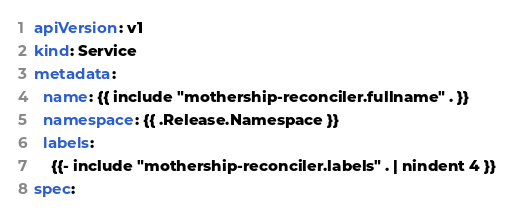<code> <loc_0><loc_0><loc_500><loc_500><_YAML_>apiVersion: v1
kind: Service
metadata:
  name: {{ include "mothership-reconciler.fullname" . }}
  namespace: {{ .Release.Namespace }}
  labels:
    {{- include "mothership-reconciler.labels" . | nindent 4 }}
spec:</code> 